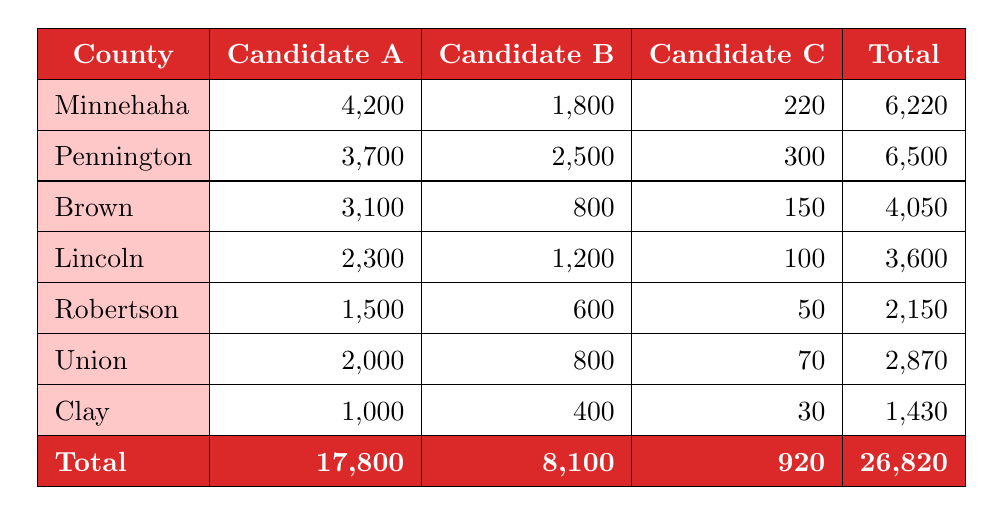What is the total support for Candidate A across all counties? To find the total support for Candidate A, sum the values from the "Candidate A" column. These values are 4200 (Minnehaha) + 3700 (Pennington) + 3100 (Brown) + 2300 (Lincoln) + 1500 (Robertson) + 2000 (Union) + 1000 (Clay) = 17800.
Answer: 17800 Which county gave the highest support to Candidate B? Looking at the "Candidate B" column, the values are 1800 (Minnehaha), 2500 (Pennington), 800 (Brown), 1200 (Lincoln), 600 (Robertson), 800 (Union), and 400 (Clay). The highest value is 2500 in Pennington.
Answer: Pennington Is the total support for Candidate C greater than 1000? To answer this, sum the values from the "Candidate C" column: 220 (Minnehaha) + 300 (Pennington) + 150 (Brown) + 100 (Lincoln) + 50 (Robertson) + 70 (Union) + 30 (Clay) = 920, which is less than 1000.
Answer: No What is the average support for Candidate A in the counties listed? To calculate the average, sum the support for Candidate A (17800) and divide by the number of counties (7): 17800 / 7 = 2542.857, rounding to two decimal places gives approximately 2542.86.
Answer: 2542.86 Which candidate received the least total support from all counties? To find this, sum the total supports for each candidate: A: 17800, B: 8100, C: 920. Candidate C has the lowest total support of 920.
Answer: Candidate C In how many counties did Candidate A receive more than 2000 votes? Checking the "Candidate A" column, the values are 4200 (Minnehaha), 3700 (Pennington), 3100 (Brown), 2300 (Lincoln), and 2000 (Union), which are all greater than 2000. Candidate A received more than 2000 support in 5 counties.
Answer: 5 What is the difference in total support between Candidate A and Candidate B? The total support for Candidate A is 17800, and for Candidate B, it is 8100. The difference is 17800 - 8100 = 9700.
Answer: 9700 Which county had the lowest total support overall? Checking the "Total" column: Minnehaha: 6220, Pennington: 6500, Brown: 4050, Lincoln: 3600, Robertson: 2150, Union: 2870, and Clay: 1430. Clay has the lowest value of 1430.
Answer: Clay 